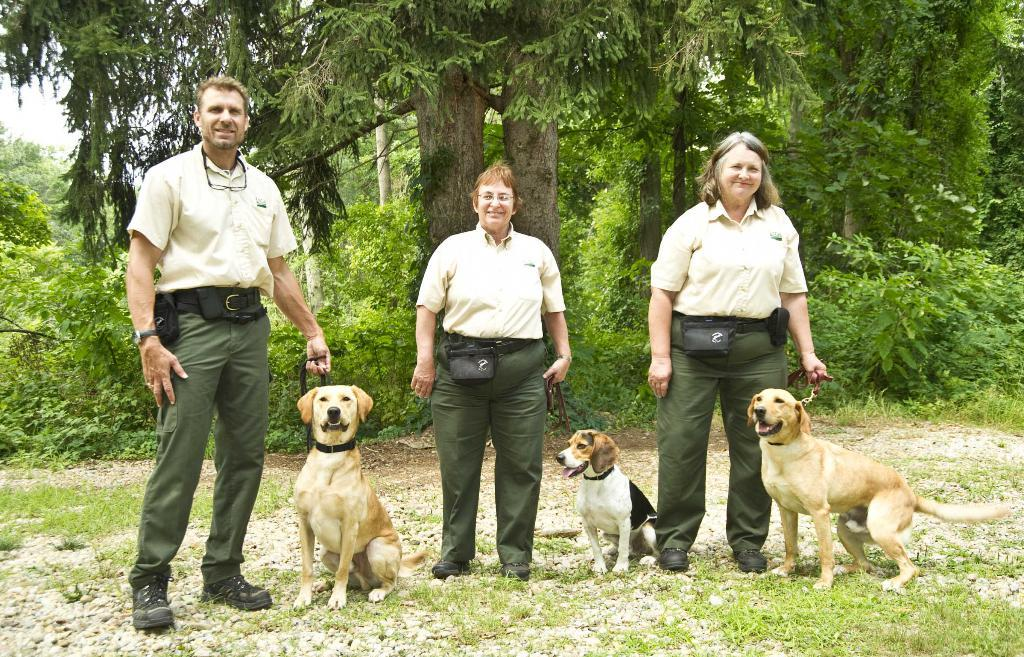What are the persons in the image doing? The persons in the image are standing on the ground and holding dogs in their hands. What can be seen in the background of the image? There are plants, trees, and the sky visible in the background of the image. How many chickens are present in the image? There are no chickens present in the image; it features persons holding dogs. Can you describe the health of the plants in the image? The provided facts do not mention the health of the plants, only their presence in the background. 